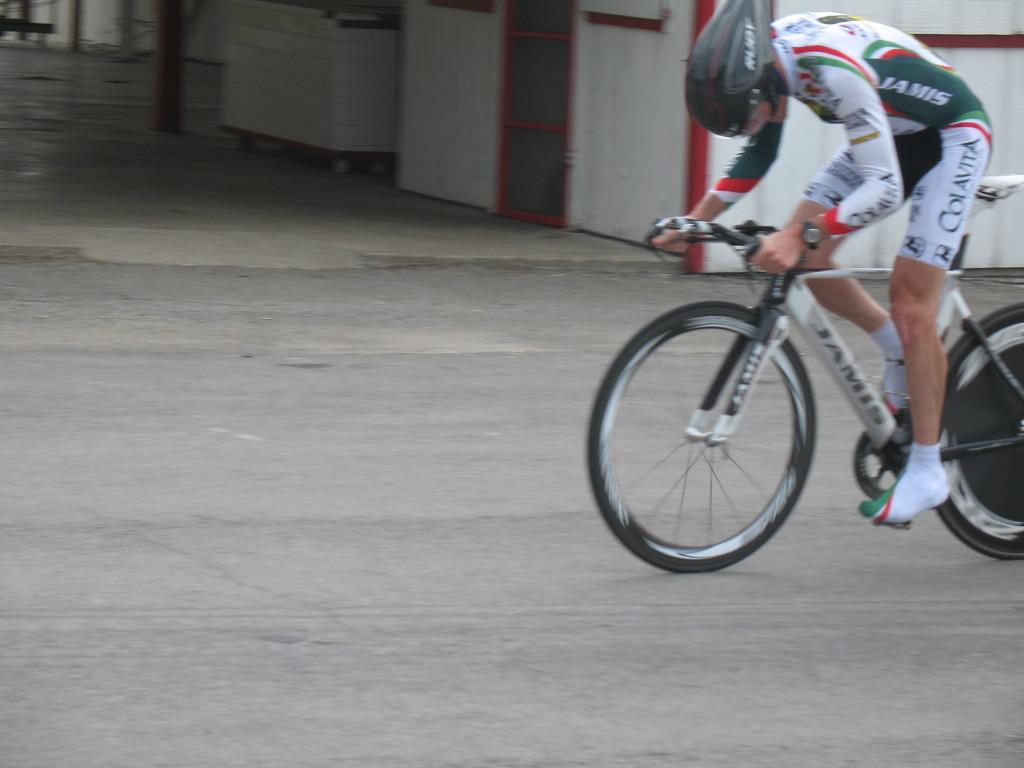How would you summarize this image in a sentence or two? On the right side of the image, we can see a person riding a bicycle on the road and wearing a helmet. At the top of the image, we can see box, shelter and poles. 